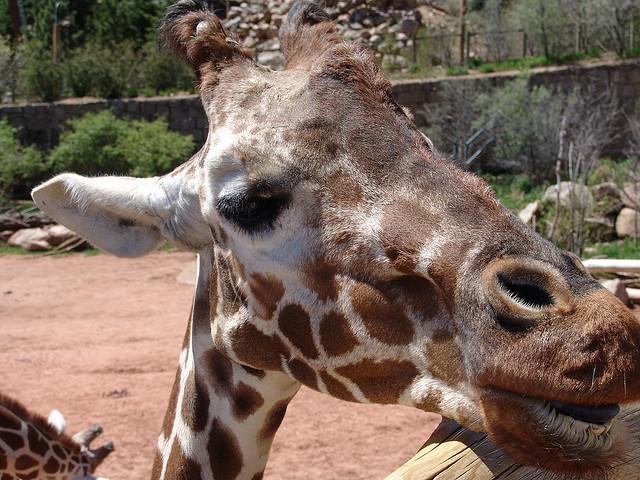How many giraffes are there?
Give a very brief answer. 2. How many people are in this picture?
Give a very brief answer. 0. 